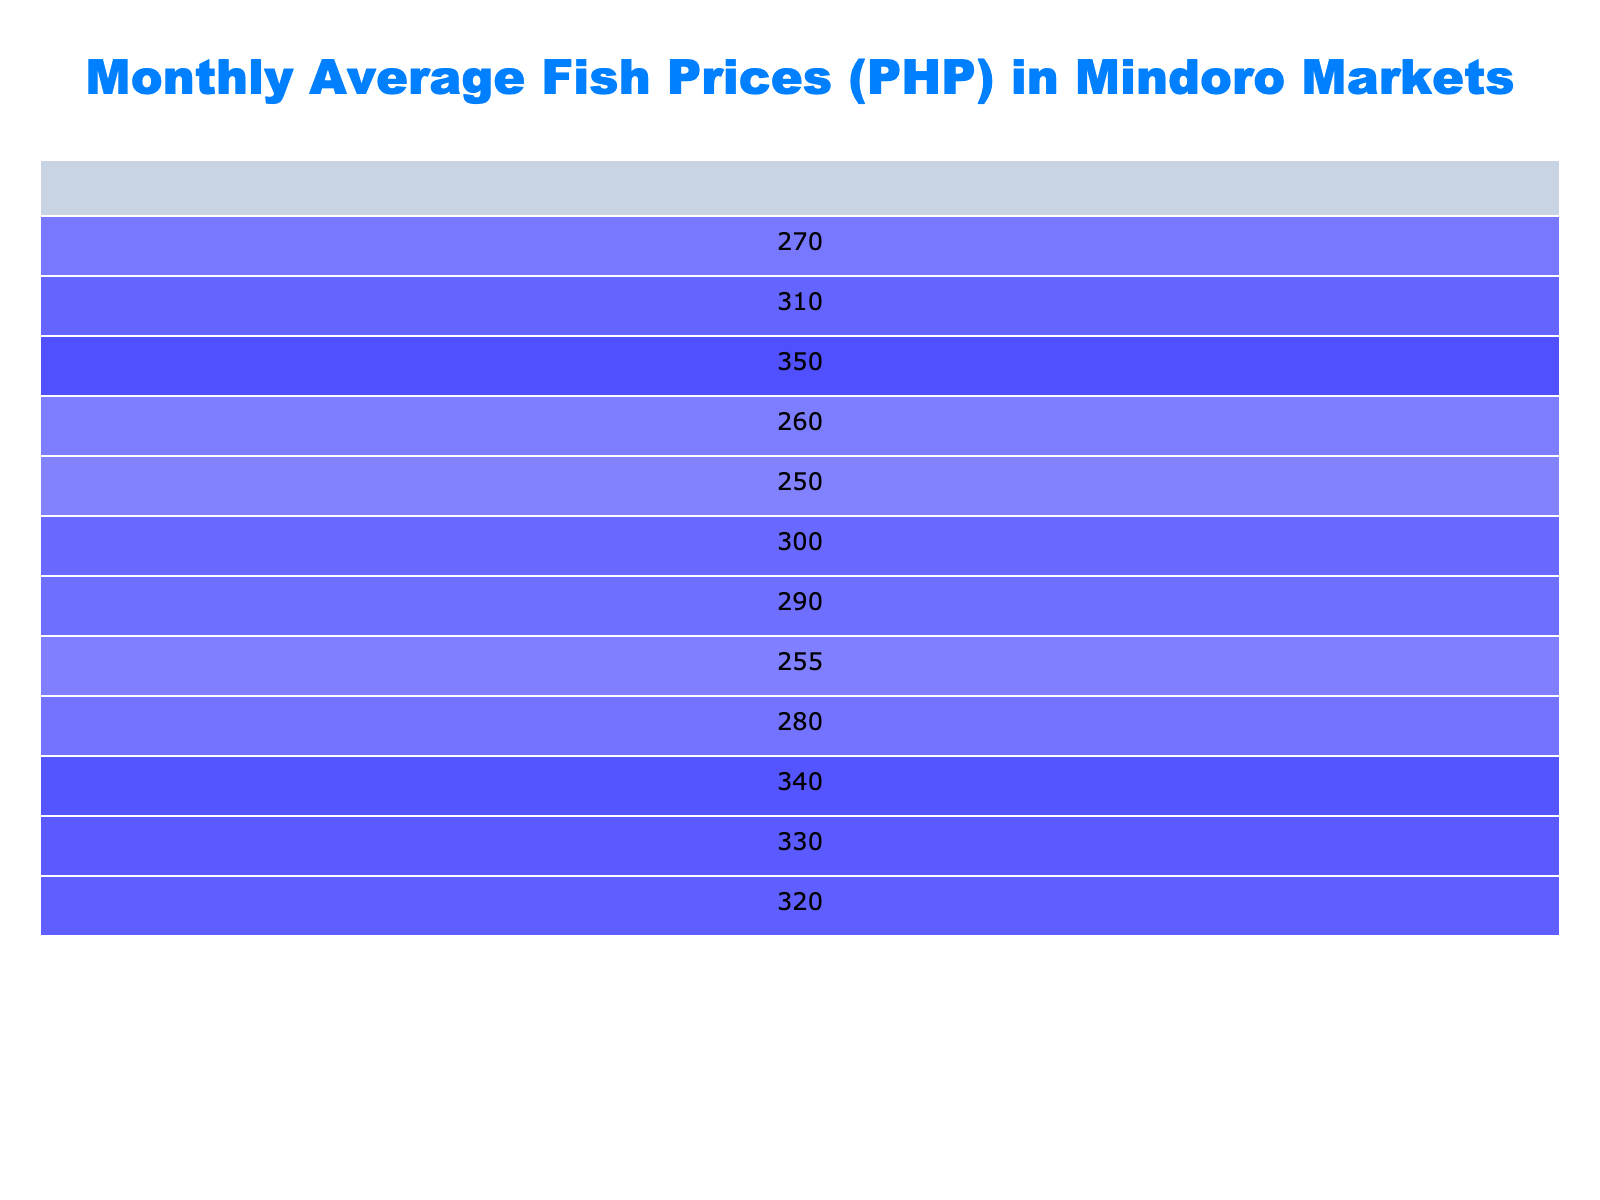What is the average price of Yellowfin Tuna in October? The table shows the average price of Yellowfin Tuna in October is 330 PHP.
Answer: 330 PHP What is the highest average price for Shrimp across all months? The highest average price for Shrimp in the table is 450 PHP in December.
Answer: 450 PHP In which month did the average price of Milkfish first exceed 250 PHP? By looking at the prices for Milkfish, the average price first exceeds 250 PHP in July, where it is 255 PHP.
Answer: July What is the price difference between the average price of Mackerel in January and September? The average price of Mackerel in January is 180 PHP and in September it is 240 PHP. The difference is 240 - 180 = 60 PHP.
Answer: 60 PHP Is the average price of Shrimp consistently increasing every month? Upon reviewing the table, the average price of Shrimp does not consistently increase as it decreased in March (340 PHP) and then resumed increasing in subsequent months. Thus, the statement is false.
Answer: No Which species saw the largest increase in average price from April to May? Analyzing the data, the average price of Yellowfin Tuna increased from 270 PHP in April to 280 PHP in May, resulting in a 10 PHP increase. Comparatively, the highest increase was for Shrimp, which went from 370 PHP in April to 375 PHP in May, which is only a 5 PHP increase. Therefore, Yellowfin Tuna saw the largest increase.
Answer: Yellowfin Tuna What is the average price of Mackerel over the months listed? The average prices of Mackerel for each month are as follows: 180, 175, 190, 200, 210, 220, 215, 230, 240, 245, 250, and 255 PHP. Summing these gives 2,550 PHP, and dividing by 12 (the number of months) results in an average of 212.5 PHP.
Answer: 212.5 PHP Which local market consistently has the highest average prices for all fish species? From the table, Puerto Galera Market has consistently higher prices for Yellowfin Tuna and Milkfish, while Calapan City Market has the highest prices for Shrimp in every month, indicating that Puerto Galera and Calapan City are key markets. However, the specific market cannot be marked as consistently the highest across all species.
Answer: No consistent highest market 